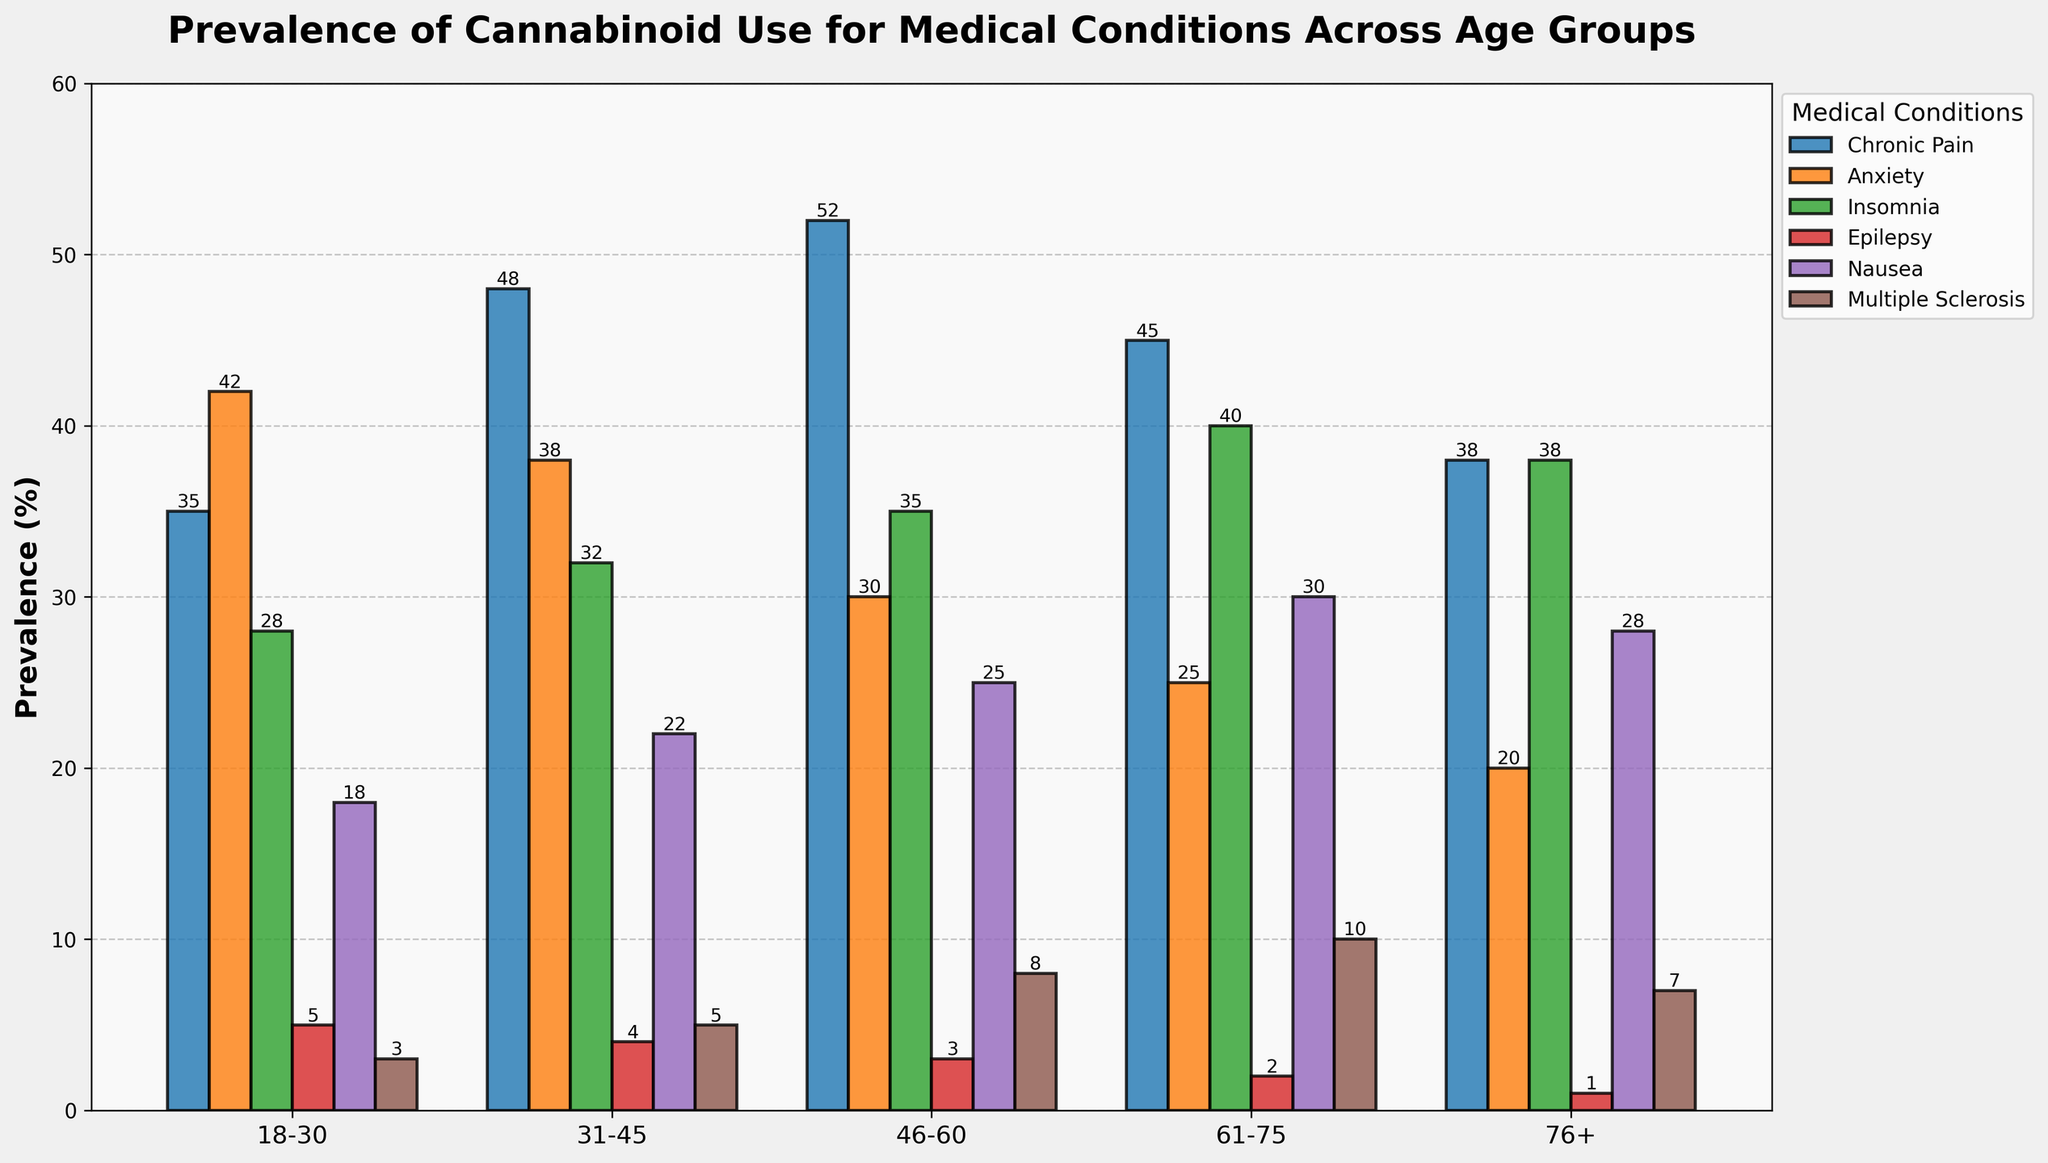What is the most prevalent medical condition treated with cannabinoids for the age group 46-60? Look at the data for the 46-60 age group and identify which condition has the highest prevalence. In this case, Chronic Pain has the highest value of 52.
Answer: Chronic Pain Which age group has the highest prevalence of cannabinoid use for anxiety? Compare the prevalence values of Anxiety across all age groups. The age group 18-30 has the highest value of 42.
Answer: 18-30 Among the age groups 31-45 and 61-75, which one has a higher prevalence of cannabinoid use for Multiple Sclerosis? Compare the values of Multiple Sclerosis for the age groups 31-45 and 61-75. Age group 61-75 has a higher value of 10 compared to 5.
Answer: 61-75 What is the difference in prevalence of cannabinoid use for Insomnia between the age groups 18-30 and 61-75? Subtract the prevalence of Insomnia in the 18-30 age group from that in the 61-75 age group: 40 - 28 = 12.
Answer: 12 Which medical condition has the least prevalence for the age group 76+? Look at the values for the age group 76+ and identify the condition with the lowest prevalence. Epilepsy has the lowest value of 1.
Answer: Epilepsy What is the total prevalence of cannabinoid use for Chronic Pain and Anxiety in the age group 31-45? Add the prevalence values for Chronic Pain and Anxiety in the 31-45 age group: 48 + 38 = 86.
Answer: 86 Which condition shows an increasing trend in prevalence from the age group 18-30 to 76+? Check the values for all conditions across age groups 18-30 to 76+. Chronic Pain peaks at 46-60 and then decreases. Only Insomnia shows an increasing trend: 28, 32, 35, 40, 38.
Answer: Insomnia What is the average prevalence of cannabinoid use for Nausea across all age groups? Sum the prevalence values for Nausea across all age groups and divide by the number of age groups: (18 + 22 + 25 + 30 + 28) / 5 = 24.6.
Answer: 24.6 By how much does the prevalence of cannabinoid use for Chronic Pain in the 46-60 age group exceed that in the 18-30 age group? Subtract the value for Chronic Pain in the 18-30 age group from that in the 46-60 age group: 52 - 35 = 17.
Answer: 17 Does any age group have a prevalence of cannabinoid use for Epilepsy greater than 5%? Check the values for Epilepsy in all age groups. None of the values exceed 5%.
Answer: No 